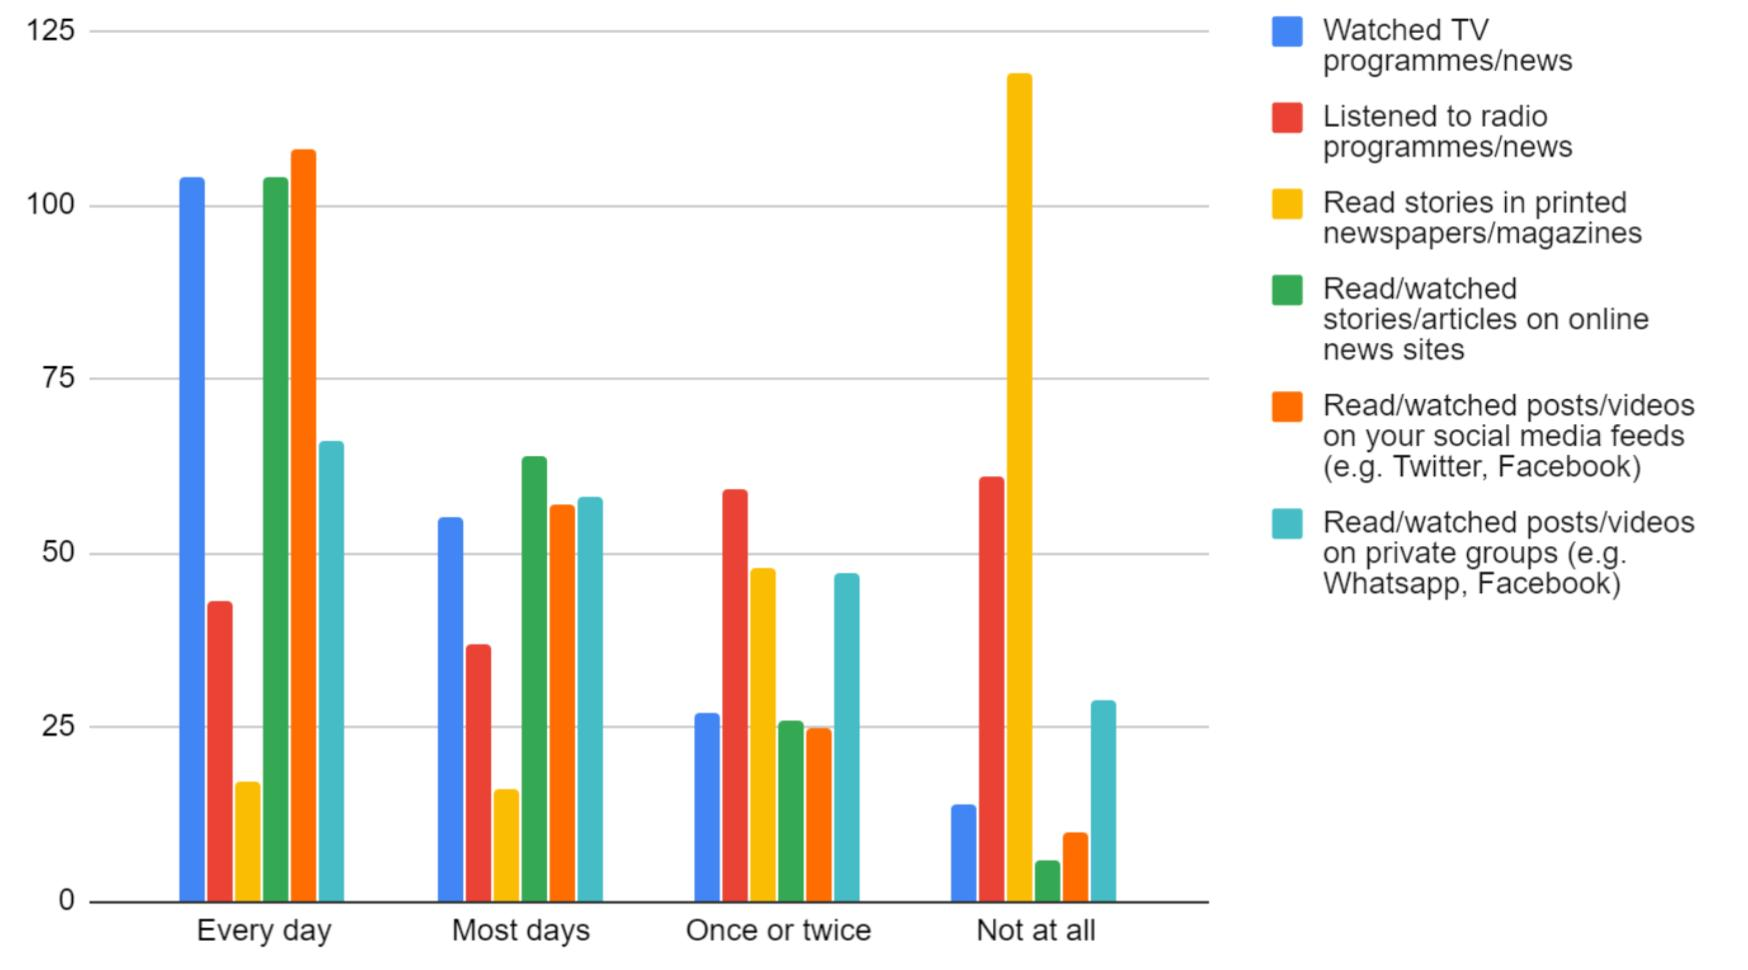Draw attention to some important aspects in this diagram. The color orange is used to represent "watched posts. The color used to represent "Listened to radio programs/news" is red. 